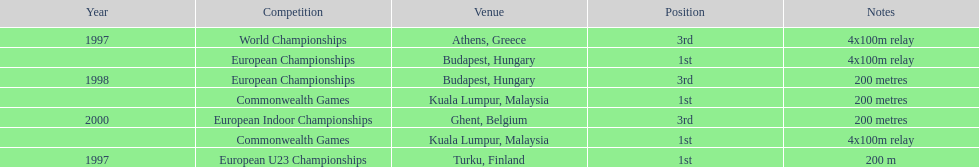What was the length of the sprint during the 2000 european indoor championships competition? 200 metres. 